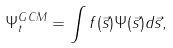<formula> <loc_0><loc_0><loc_500><loc_500>\Psi _ { t } ^ { G C M } = \int f ( \vec { s } ) \Psi ( \vec { s } ) d \vec { s } ,</formula> 